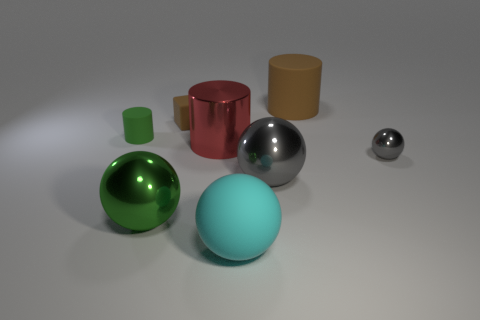Subtract all blue cubes. How many gray balls are left? 2 Subtract all large balls. How many balls are left? 1 Add 2 brown matte blocks. How many objects exist? 10 Subtract 2 spheres. How many spheres are left? 2 Subtract all green spheres. How many spheres are left? 3 Subtract all cyan cylinders. Subtract all blue cubes. How many cylinders are left? 3 Add 8 cubes. How many cubes are left? 9 Add 7 brown cylinders. How many brown cylinders exist? 8 Subtract 0 blue cylinders. How many objects are left? 8 Subtract all cylinders. How many objects are left? 5 